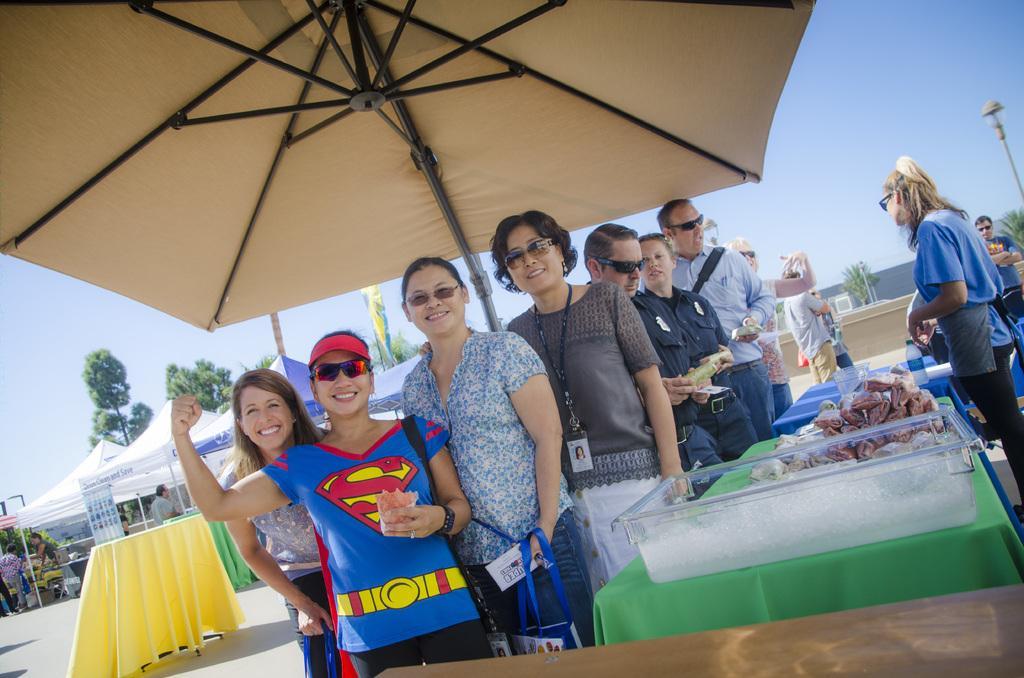Describe this image in one or two sentences. In this image there are group of people standing under the umbrella, and there are some objects on the tables, and at the background there are stalls, group of people, banner, flag, poles, lights, trees, wall, sky. 